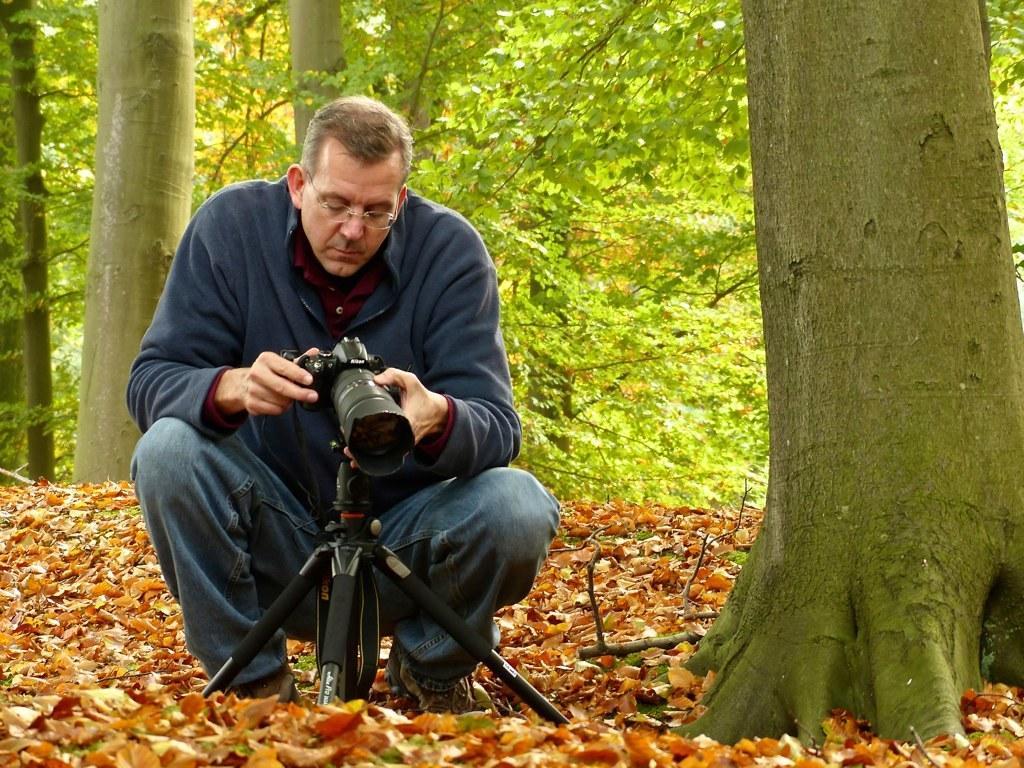Can you describe this image briefly? As we can see in the image there are trees and a man holding camera. 